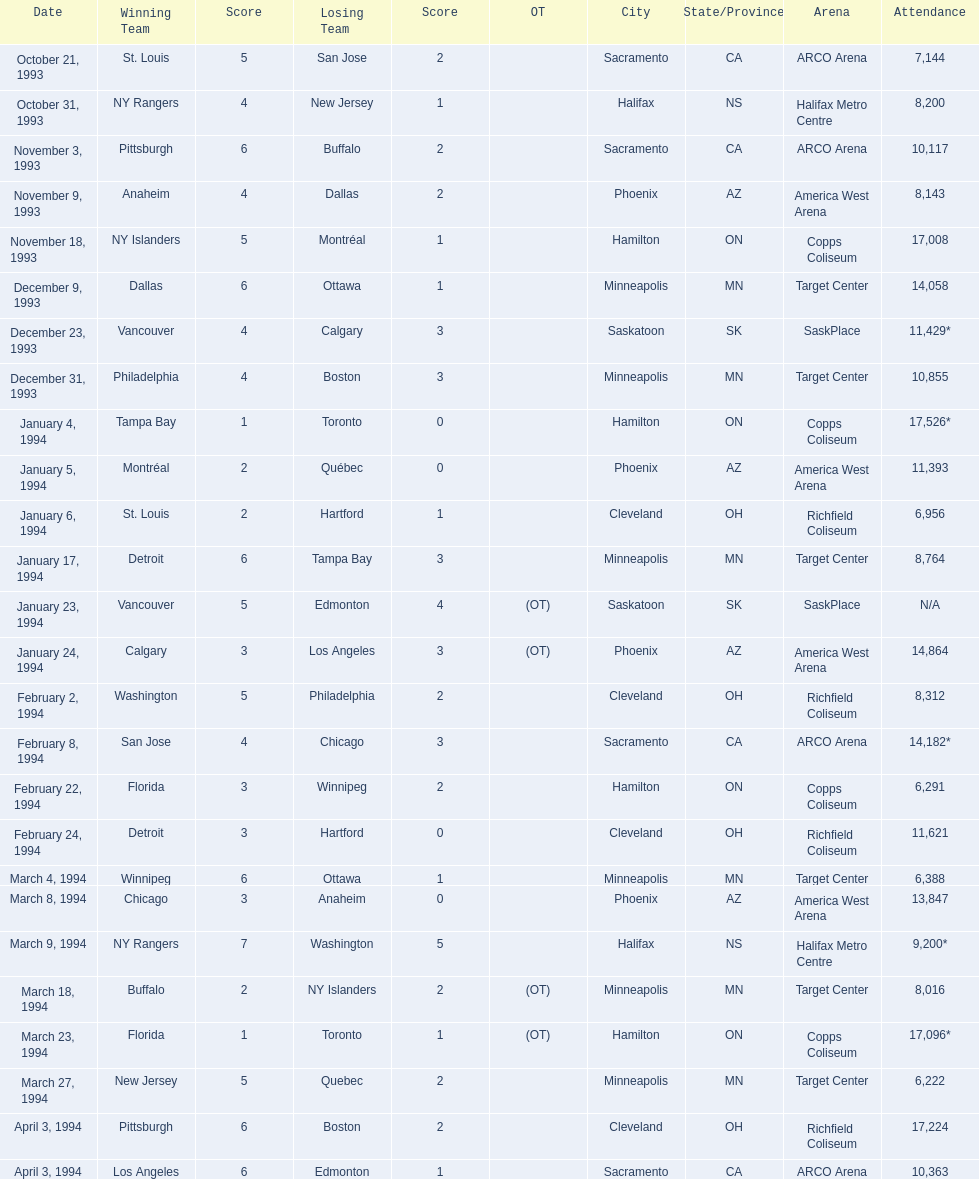When were the games where the winning team scored a single point? January 4, 1994, March 23, 1994. Out of these, which game had more spectators? January 4, 1994. 